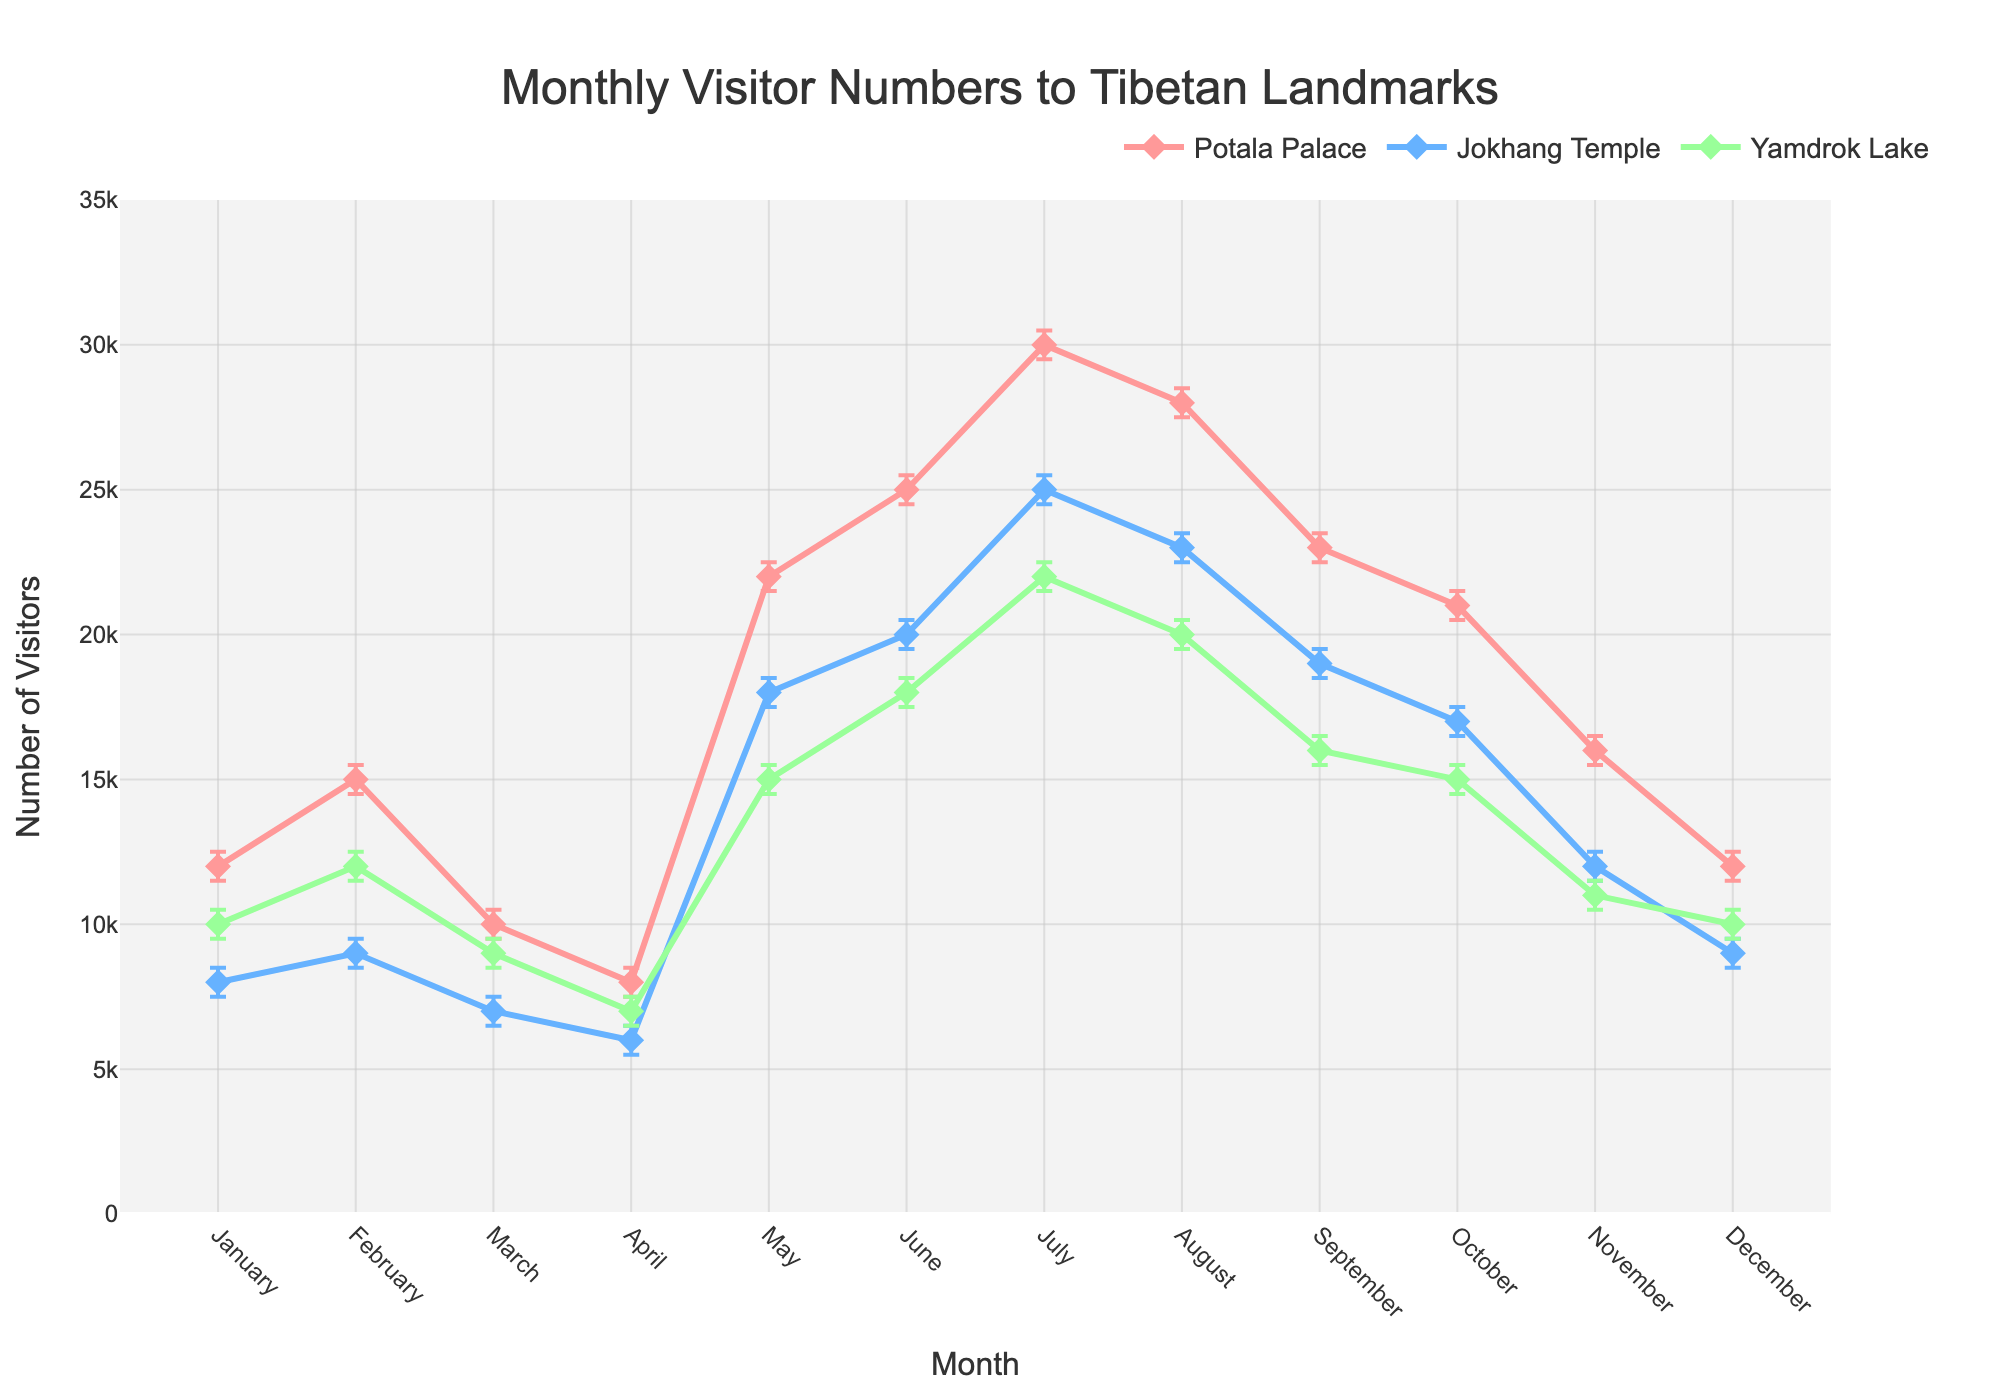What is the title of the figure? The title of a figure is typically displayed at the top and serves to inform the viewer about the data being presented. In this figure, the title is clearly stated.
Answer: Monthly Visitor Numbers to Tibetan Landmarks What are the three landmarks shown in the figure? The figure shows three lines representing different landmarks. Each line corresponds to a specific landmark as indicated in the legend.
Answer: Potala Palace, Jokhang Temple, Yamdrok Lake Which month has the highest number of visitors for Potala Palace? To find this, look for the peak of the line representing Potala Palace, which corresponds to the highest value on the y-axis.
Answer: July How does the visitor trend of Jokhang Temple in October compare with Yamdrok Lake in November? Compare the data points for Jokhang Temple in October and Yamdrok Lake in November by assessing the y-values. This involves reading the numbers from the respective months for each landmark.
Answer: Jokhang Temple has 17,000 visitors in October, and Yamdrok Lake has 11,000 visitors in November What is the range of visitor numbers for Yamdrok Lake in March? The range is given by the lower confidence interval (CI) subtracted from the upper CI.
Answer: 10,000 - 8,500 = 1,500 What is the overall trend of visitor numbers to Potala Palace from January to December? The trend is observed by noting the rise and fall pattern of the Potala Palace line over months. This comprises identifying initial values, peaks, and subsequent declines.
Answer: The trend rises to a peak in July and then gradually declines Which landmark experienced the most stable visitor numbers across the year based on the error bars? Stability can be gauged by the length of error bars; shorter error bars imply less variability. Compare error bars across the landmarks.
Answer: Jokhang Temple In which month did all three landmarks observe their lowest number of visitors? Identify the month with the lowest data points for Potala Palace, Jokhang Temple, and Yamdrok Lake, cross-referencing these points.
Answer: April During which month are the confidence intervals widest for Potala Palace? The width of the confidence interval is the difference between upper and lower CI. Assess each month and identify the widest interval.
Answer: July How do visitor trends compare between Potala Palace and Jokhang Temple in the peak month of July? Compare the y-values and the patterns of increase and decrease in July for both Potala Palace and Jokhang Temple.
Answer: Potala Palace has 30,000 visitors, while Jokhang Temple has 25,000 